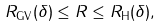<formula> <loc_0><loc_0><loc_500><loc_500>R _ { \text {GV} } ( \delta ) \leq R \leq R _ { \text  H}(\delta),</formula> 